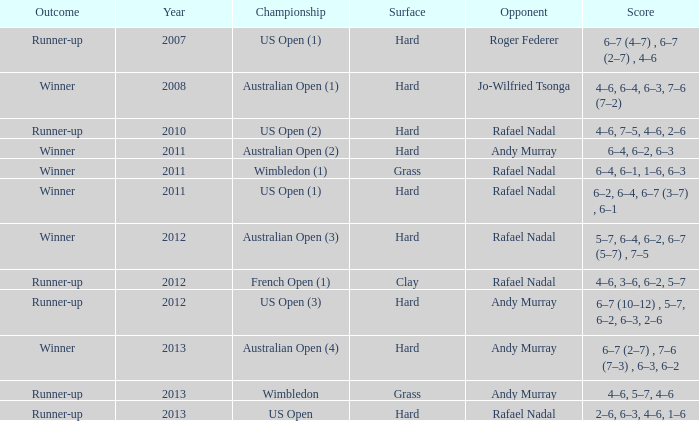What is the outcome of the match with Roger Federer as the opponent? Runner-up. 